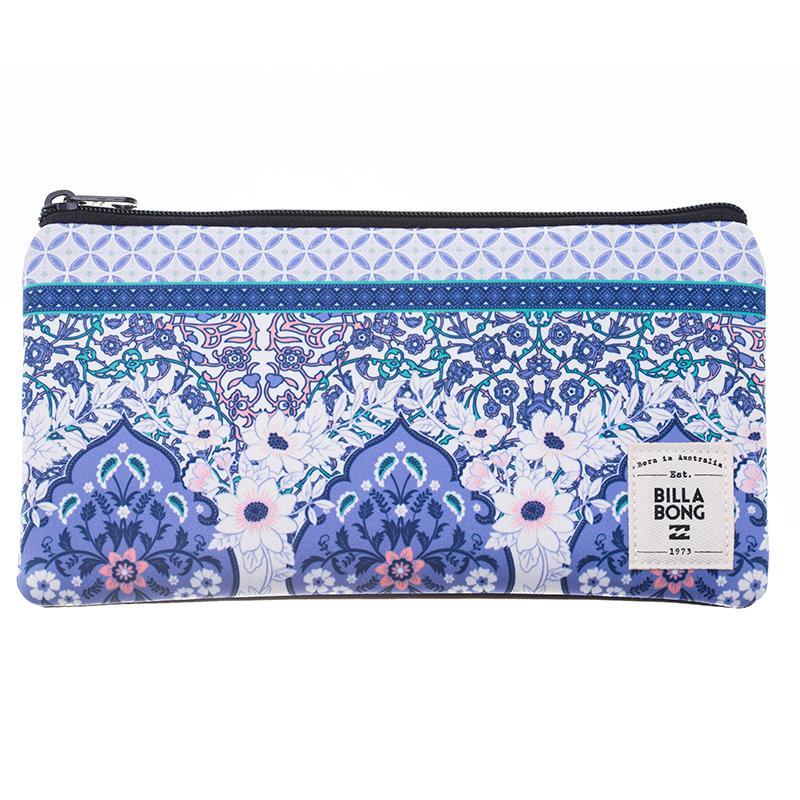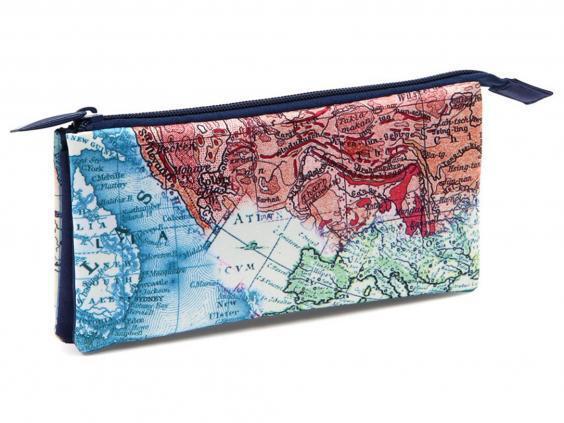The first image is the image on the left, the second image is the image on the right. Evaluate the accuracy of this statement regarding the images: "An image collage shows a pencil case that opens clam-shell style, along with the same type case closed.". Is it true? Answer yes or no. No. The first image is the image on the left, the second image is the image on the right. For the images shown, is this caption "At least of the images shows only one pencil pouch." true? Answer yes or no. Yes. 